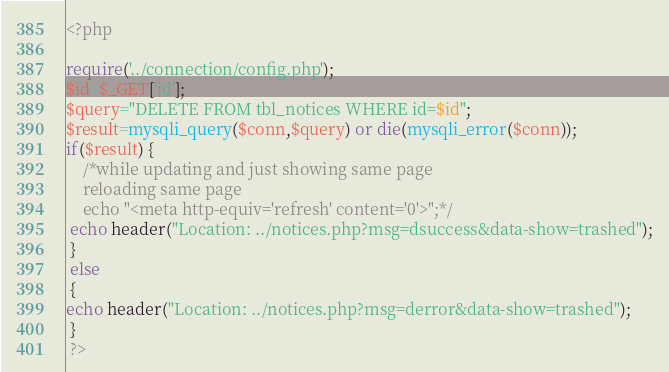<code> <loc_0><loc_0><loc_500><loc_500><_PHP_><?php

require('../connection/config.php');
$id=$_GET['id'];
$query="DELETE FROM tbl_notices WHERE id=$id";
$result=mysqli_query($conn,$query) or die(mysqli_error($conn));
if($result) {
 	/*while updating and just showing same page
 	reloading same page
 	echo "<meta http-equiv='refresh' content='0'>";*/
 echo header("Location: ../notices.php?msg=dsuccess&data-show=trashed");
 }
 else
 {
echo header("Location: ../notices.php?msg=derror&data-show=trashed");
 }
 ?>
</code> 